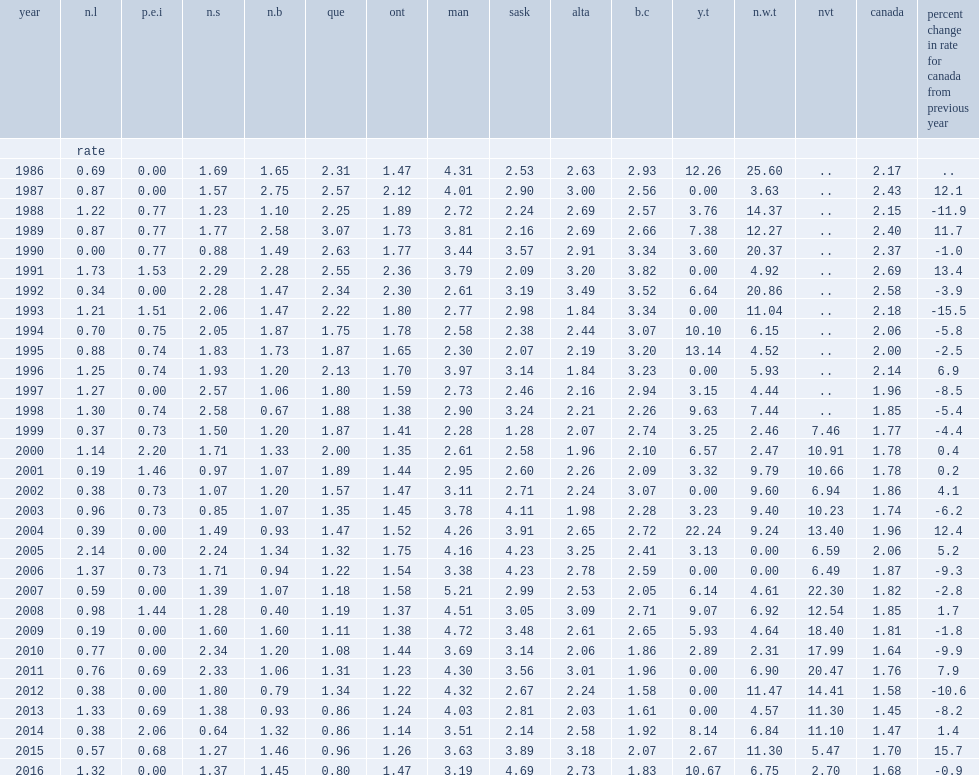What was the change in homicide rate for canada from 2015 to 2016? -0.9. Which province had the highest rate reported in 2016? Sask. Besides saskatchewan,list the top2 provinces had the highest rates among the provinces in 2016. Man alta. Among provinces that had homicides,which province had the lowest rate in 2016? Que. What were the the homicide rates in yukon in 2015 and 2016 respectively? 2.67 10.67. 